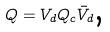<formula> <loc_0><loc_0><loc_500><loc_500>Q = V _ { d } Q _ { c } \bar { V } _ { d } \text {, }</formula> 